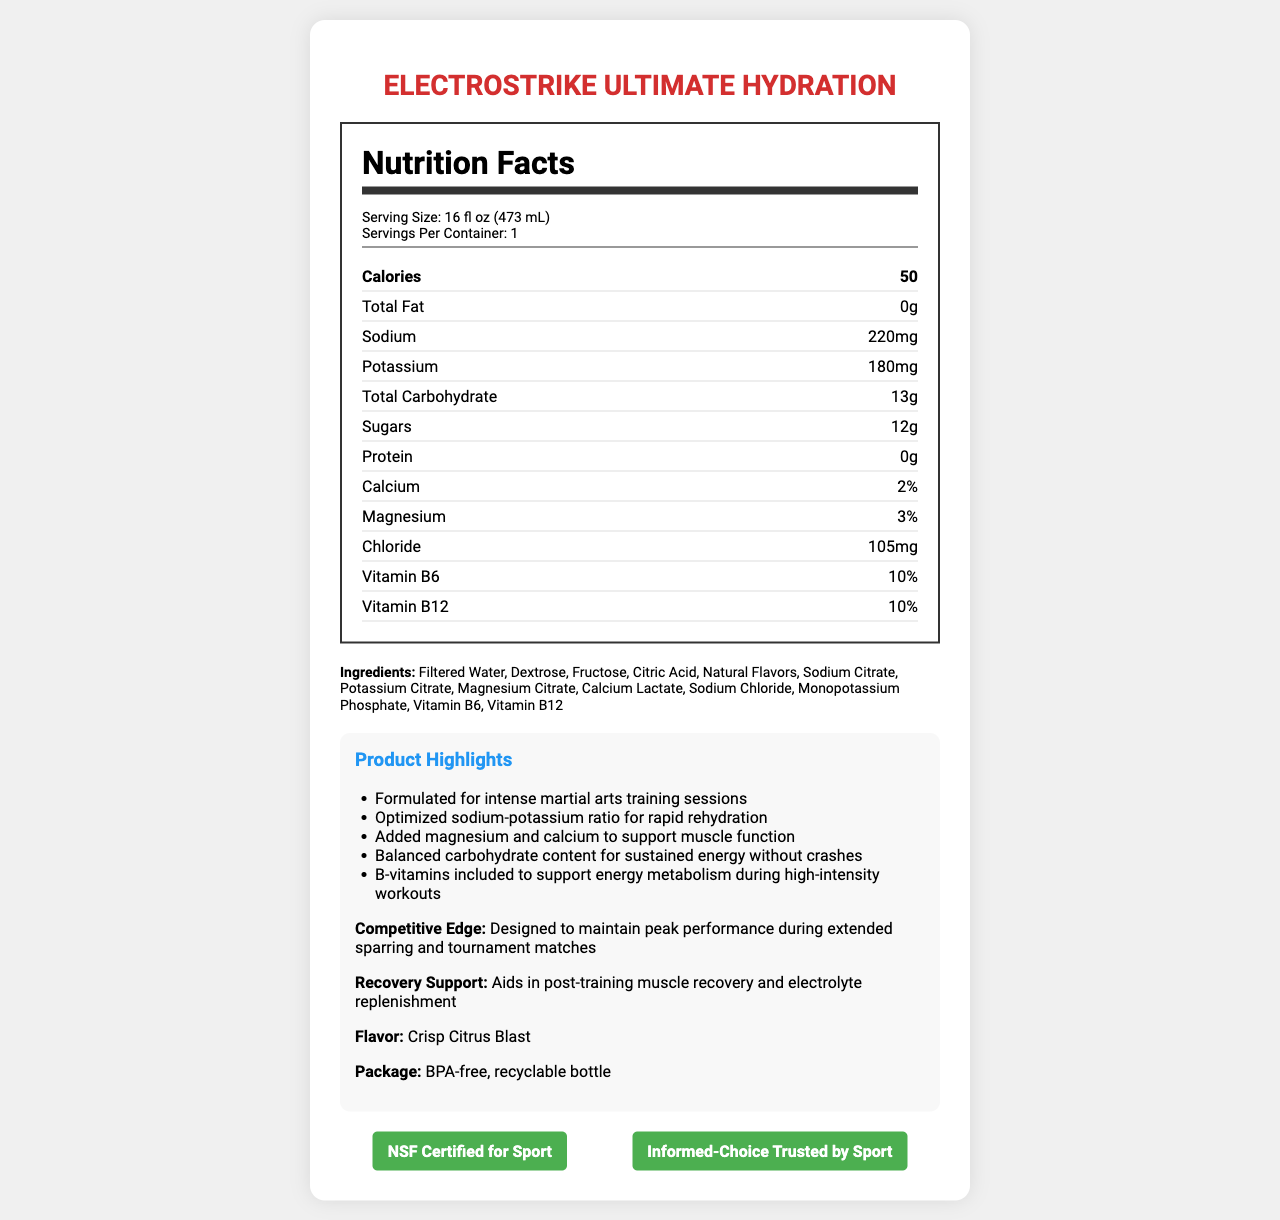what is the serving size? The serving size is stated in the serving information section of the Nutrition Facts label.
Answer: 16 fl oz (473 mL) how many calories are in a serving? The number of calories per serving is listed in the main nutrients row of the Nutrition Facts label.
Answer: 50 what is the main mineral added to support muscle function? The additional information section mentions added magnesium and calcium to support muscle function.
Answer: Magnesium and Calcium how much sodium is there per serving? The amount of sodium per serving is listed in the nutrient row in the Nutrition Facts label.
Answer: 220 mg how many grams of sugar are in a serving? The amount of sugars per serving is listed in the nutrient row in the Nutrition Facts label.
Answer: 12 grams What is the product name? The product name is mentioned at the top of the document.
Answer: ElectroStrike Ultimate Hydration which certification does the product have? A. Organic B. Gluten-Free C. NSF Certified for Sport D. Vegan The certifications section shows NSF Certified for Sport and Informed-Choice Trusted by Sport.
Answer: C which vitamin supports energy metabolism during workouts? A. Vitamin C B. Vitamin D C. Vitamin B6 D. Vitamin E The additional info section mentions that B-vitamins, including Vitamin B6, support energy metabolism during high-intensity workouts.
Answer: C Is this product suitable for intense martial arts training? The additional info section mentions that the product is formulated for intense martial arts training sessions.
Answer: Yes summarize the main idea of the document. The main idea encapsulates the product's purpose, ingredients, and certifications, along with the benefits it offers for athletic performance and hydration.
Answer: ElectroStrike Ultimate Hydration is a high-electrolyte sports drink designed for optimal hydration and performance during intense martial arts training. It contains balanced minerals, including sodium, potassium, magnesium, and calcium, and B-vitamins to support energy metabolism. The drink provides 50 calories per serving, with low sugars and carbohydrates to sustain energy without crashes. It is certified for sport safety and comes in a BPA-free, recyclable bottle. is the product organic? The document does not provide any information regarding the product being organic or not.
Answer: Not enough information 